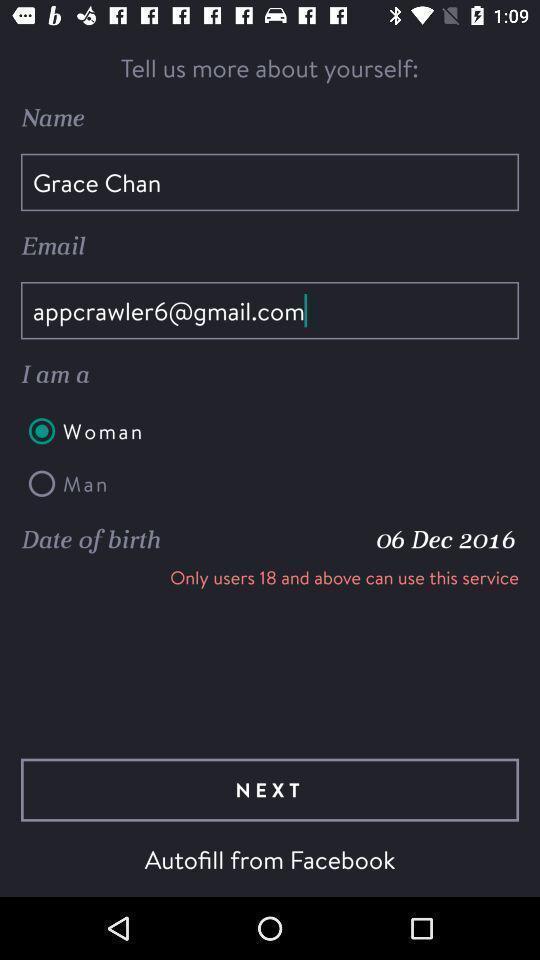What is the overall content of this screenshot? Page requesting to enter the details on an app. 